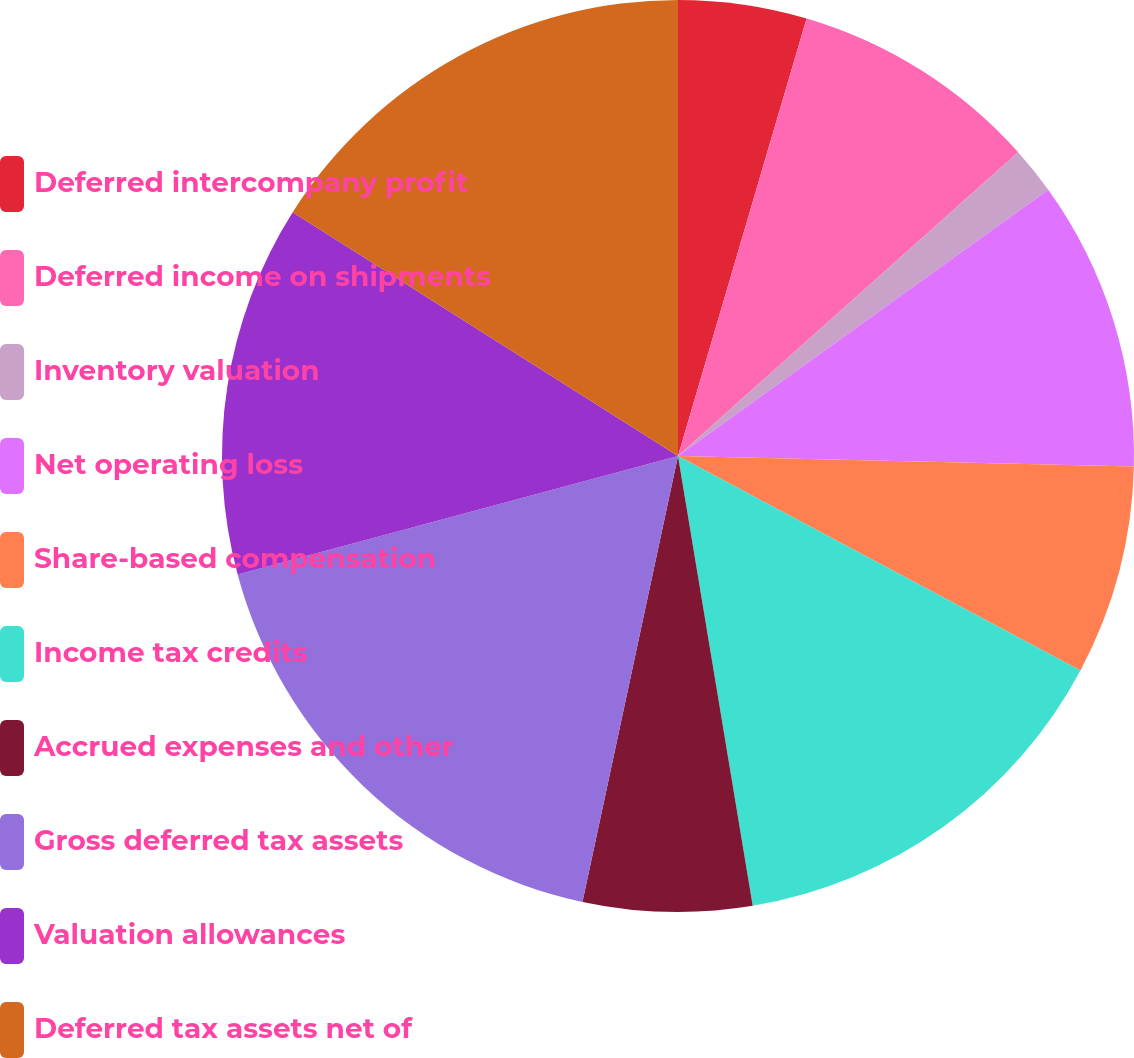<chart> <loc_0><loc_0><loc_500><loc_500><pie_chart><fcel>Deferred intercompany profit<fcel>Deferred income on shipments<fcel>Inventory valuation<fcel>Net operating loss<fcel>Share-based compensation<fcel>Income tax credits<fcel>Accrued expenses and other<fcel>Gross deferred tax assets<fcel>Valuation allowances<fcel>Deferred tax assets net of<nl><fcel>4.55%<fcel>8.85%<fcel>1.68%<fcel>10.29%<fcel>7.42%<fcel>14.59%<fcel>5.98%<fcel>17.46%<fcel>13.16%<fcel>16.02%<nl></chart> 